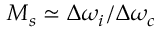<formula> <loc_0><loc_0><loc_500><loc_500>M _ { s } \simeq \Delta \omega _ { i } / \Delta \omega _ { c }</formula> 